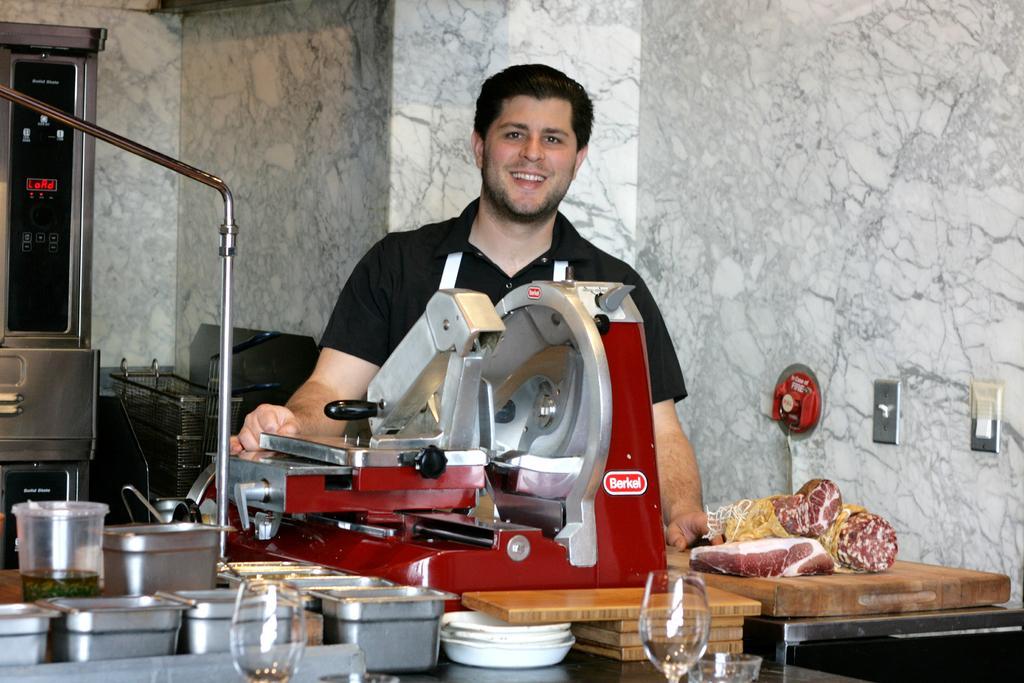Could you give a brief overview of what you see in this image? In the center of the image we can see a man is standing and smiling. At the bottom of the image we can see a table. On the table we can see the vessels, plates, glasses, flesh, containers and machine. In the background of the image we can see the wall, boards, trolley. On the left side of the image we can see a container, rod. 